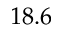<formula> <loc_0><loc_0><loc_500><loc_500>1 8 . 6</formula> 